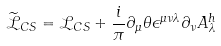Convert formula to latex. <formula><loc_0><loc_0><loc_500><loc_500>\widetilde { \mathcal { L } } _ { C S } = \mathcal { L } _ { C S } + \frac { i } { \pi } \partial _ { \mu } \theta \epsilon ^ { \mu \nu \lambda } \partial _ { \nu } A _ { \lambda } ^ { h }</formula> 